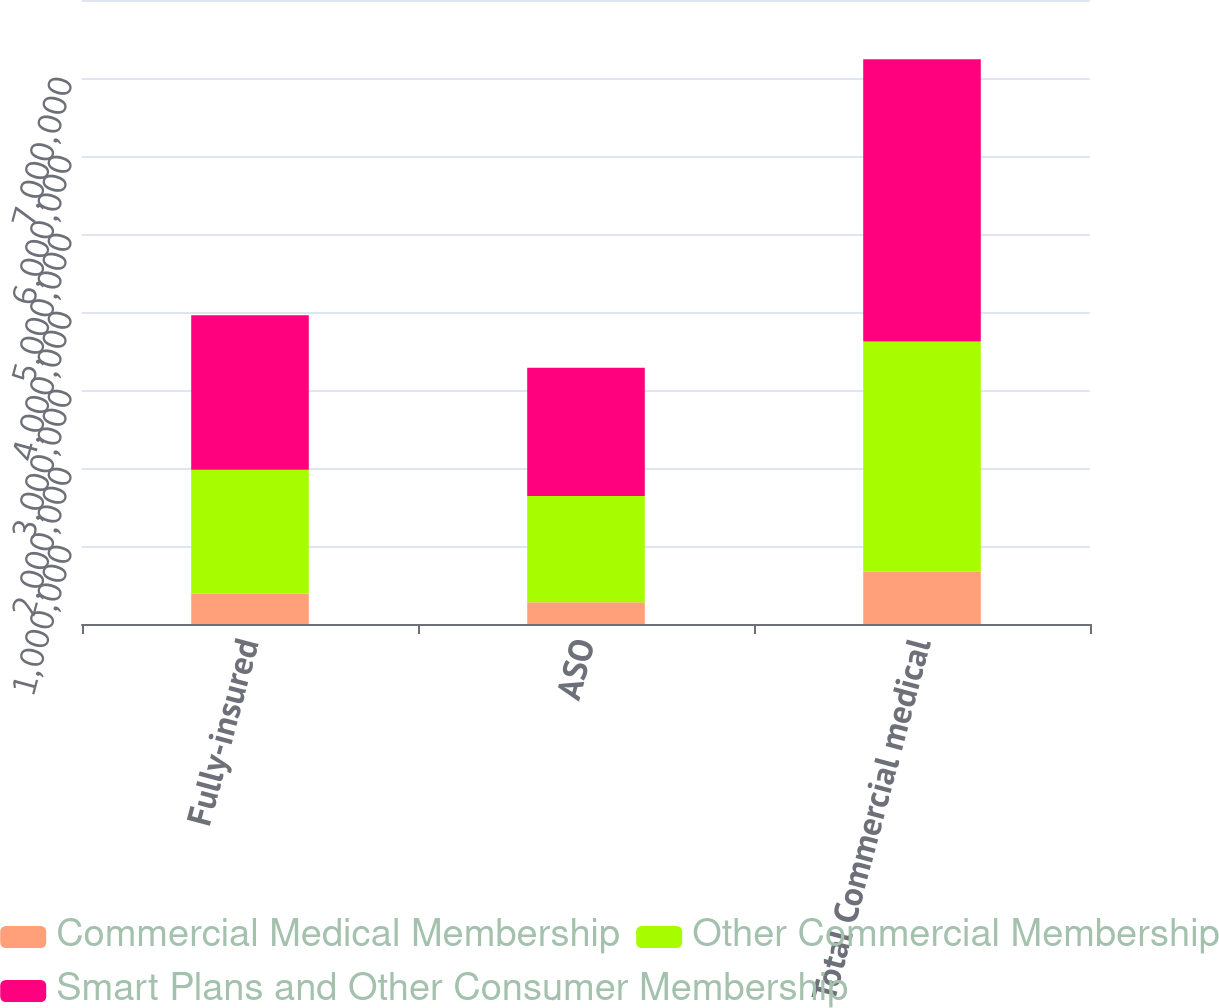Convert chart. <chart><loc_0><loc_0><loc_500><loc_500><stacked_bar_chart><ecel><fcel>Fully-insured<fcel>ASO<fcel>Total Commercial medical<nl><fcel>Commercial Medical Membership<fcel>392500<fcel>277500<fcel>670000<nl><fcel>Other Commercial Membership<fcel>1.5863e+06<fcel>1.3645e+06<fcel>2.9508e+06<nl><fcel>Smart Plans and Other Consumer Membership<fcel>1.9788e+06<fcel>1.642e+06<fcel>3.6208e+06<nl></chart> 